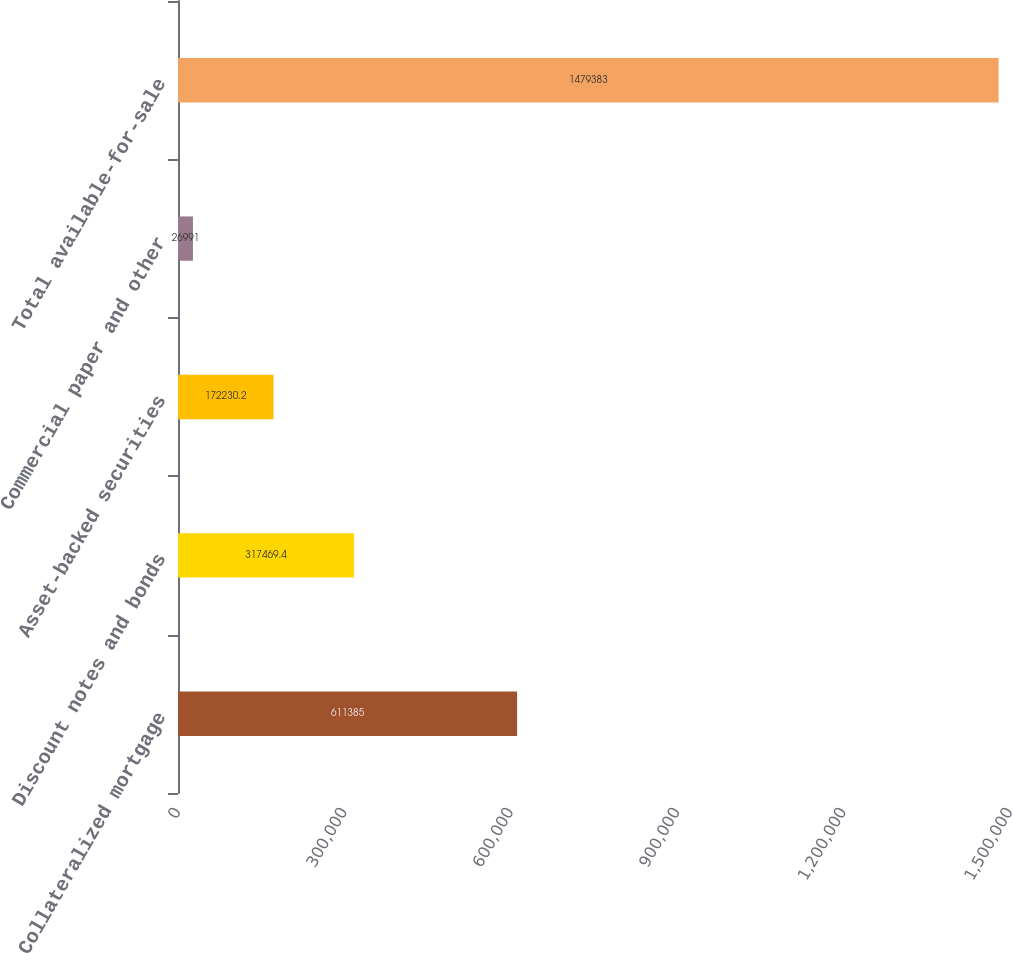<chart> <loc_0><loc_0><loc_500><loc_500><bar_chart><fcel>Collateralized mortgage<fcel>Discount notes and bonds<fcel>Asset-backed securities<fcel>Commercial paper and other<fcel>Total available-for-sale<nl><fcel>611385<fcel>317469<fcel>172230<fcel>26991<fcel>1.47938e+06<nl></chart> 